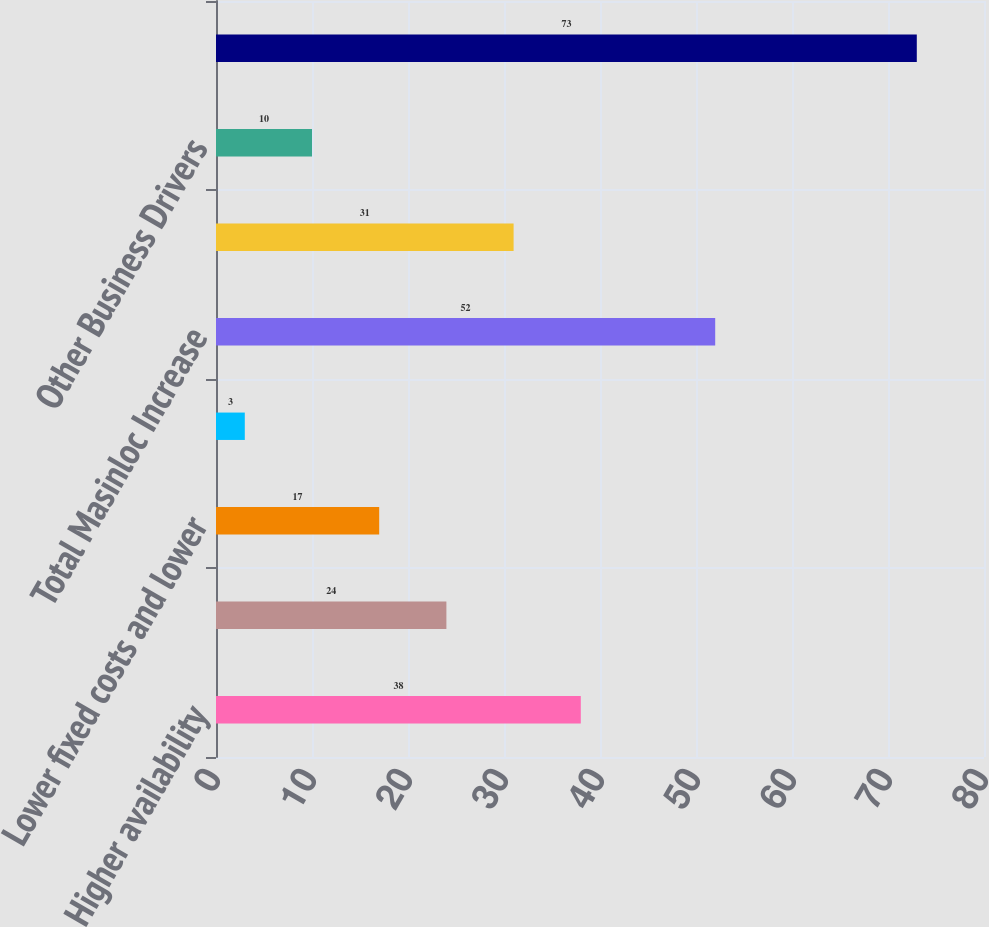Convert chart to OTSL. <chart><loc_0><loc_0><loc_500><loc_500><bar_chart><fcel>Higher availability<fcel>One-time unfavorable impact in<fcel>Lower fixed costs and lower<fcel>Other<fcel>Total Masinloc Increase<fcel>Commencement of principal<fcel>Other Business Drivers<fcel>Total Asia SBU Operating<nl><fcel>38<fcel>24<fcel>17<fcel>3<fcel>52<fcel>31<fcel>10<fcel>73<nl></chart> 